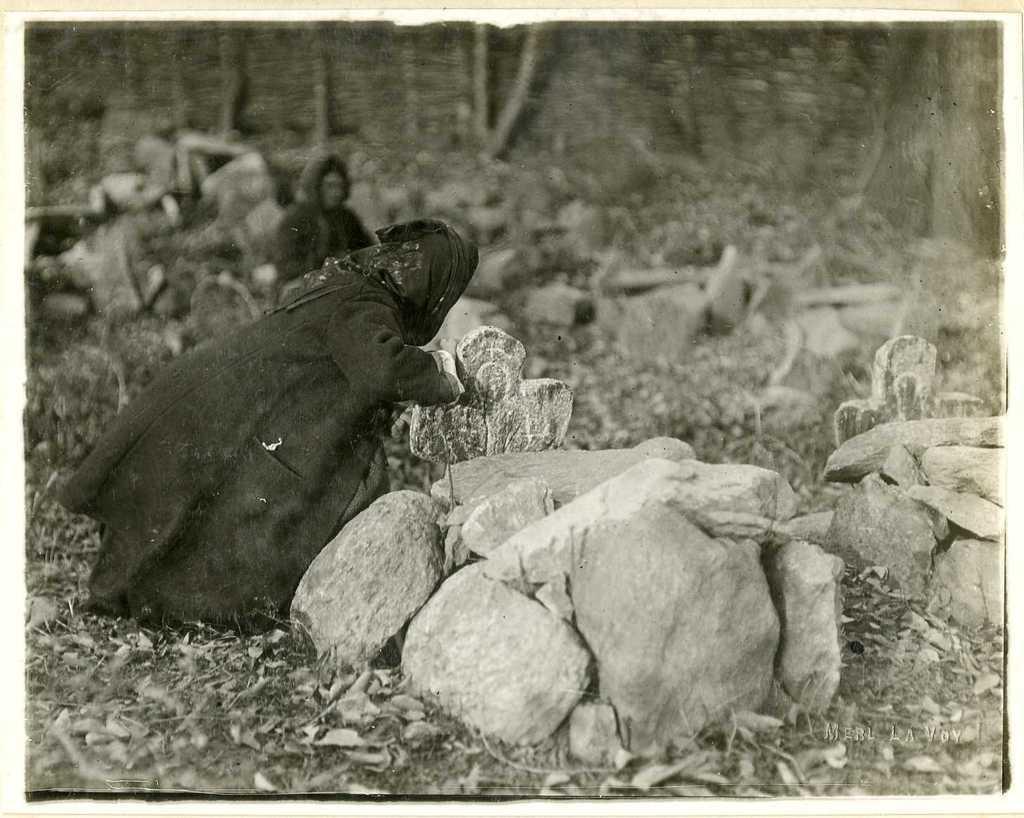Could you give a brief overview of what you see in this image? In this black and white picture two people are on the land. There are few cemeteries on the land having rocks and dried leaves. Top of the image there are trees. 